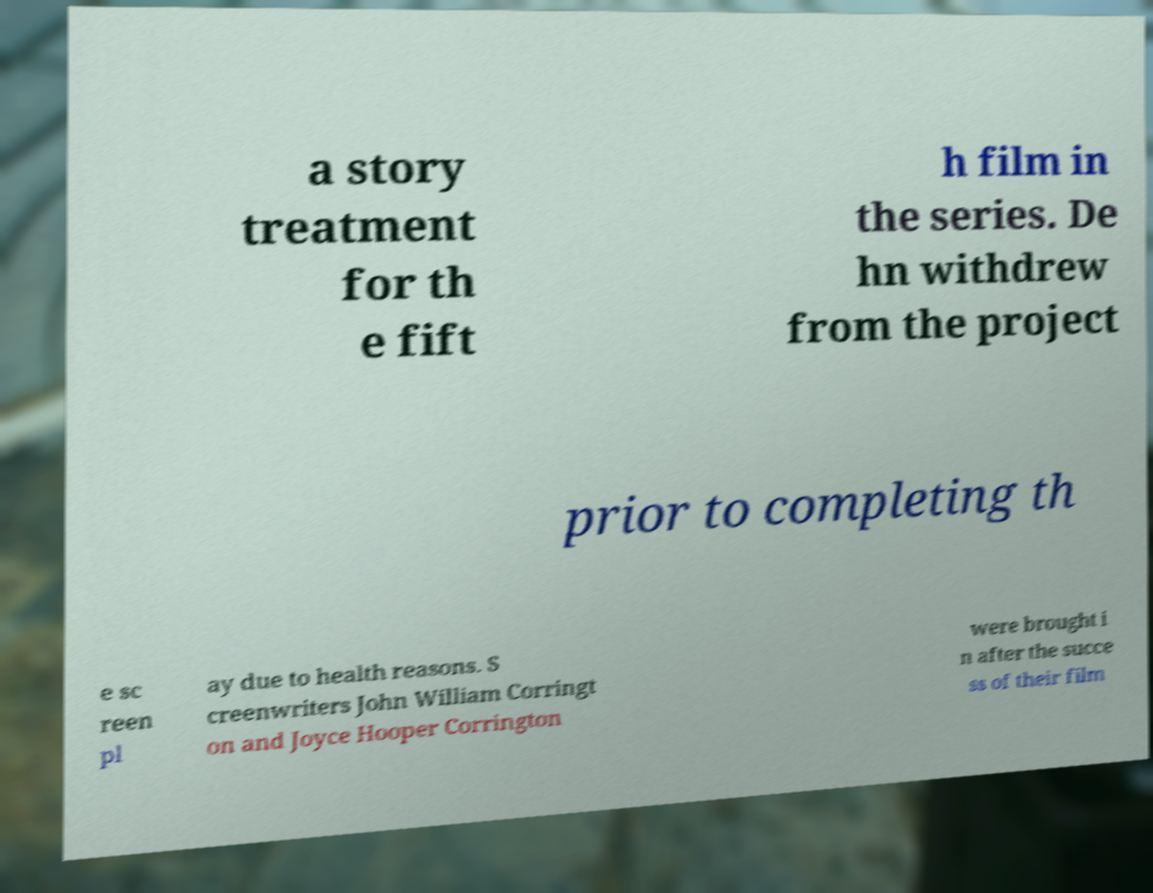What messages or text are displayed in this image? I need them in a readable, typed format. a story treatment for th e fift h film in the series. De hn withdrew from the project prior to completing th e sc reen pl ay due to health reasons. S creenwriters John William Corringt on and Joyce Hooper Corrington were brought i n after the succe ss of their film 